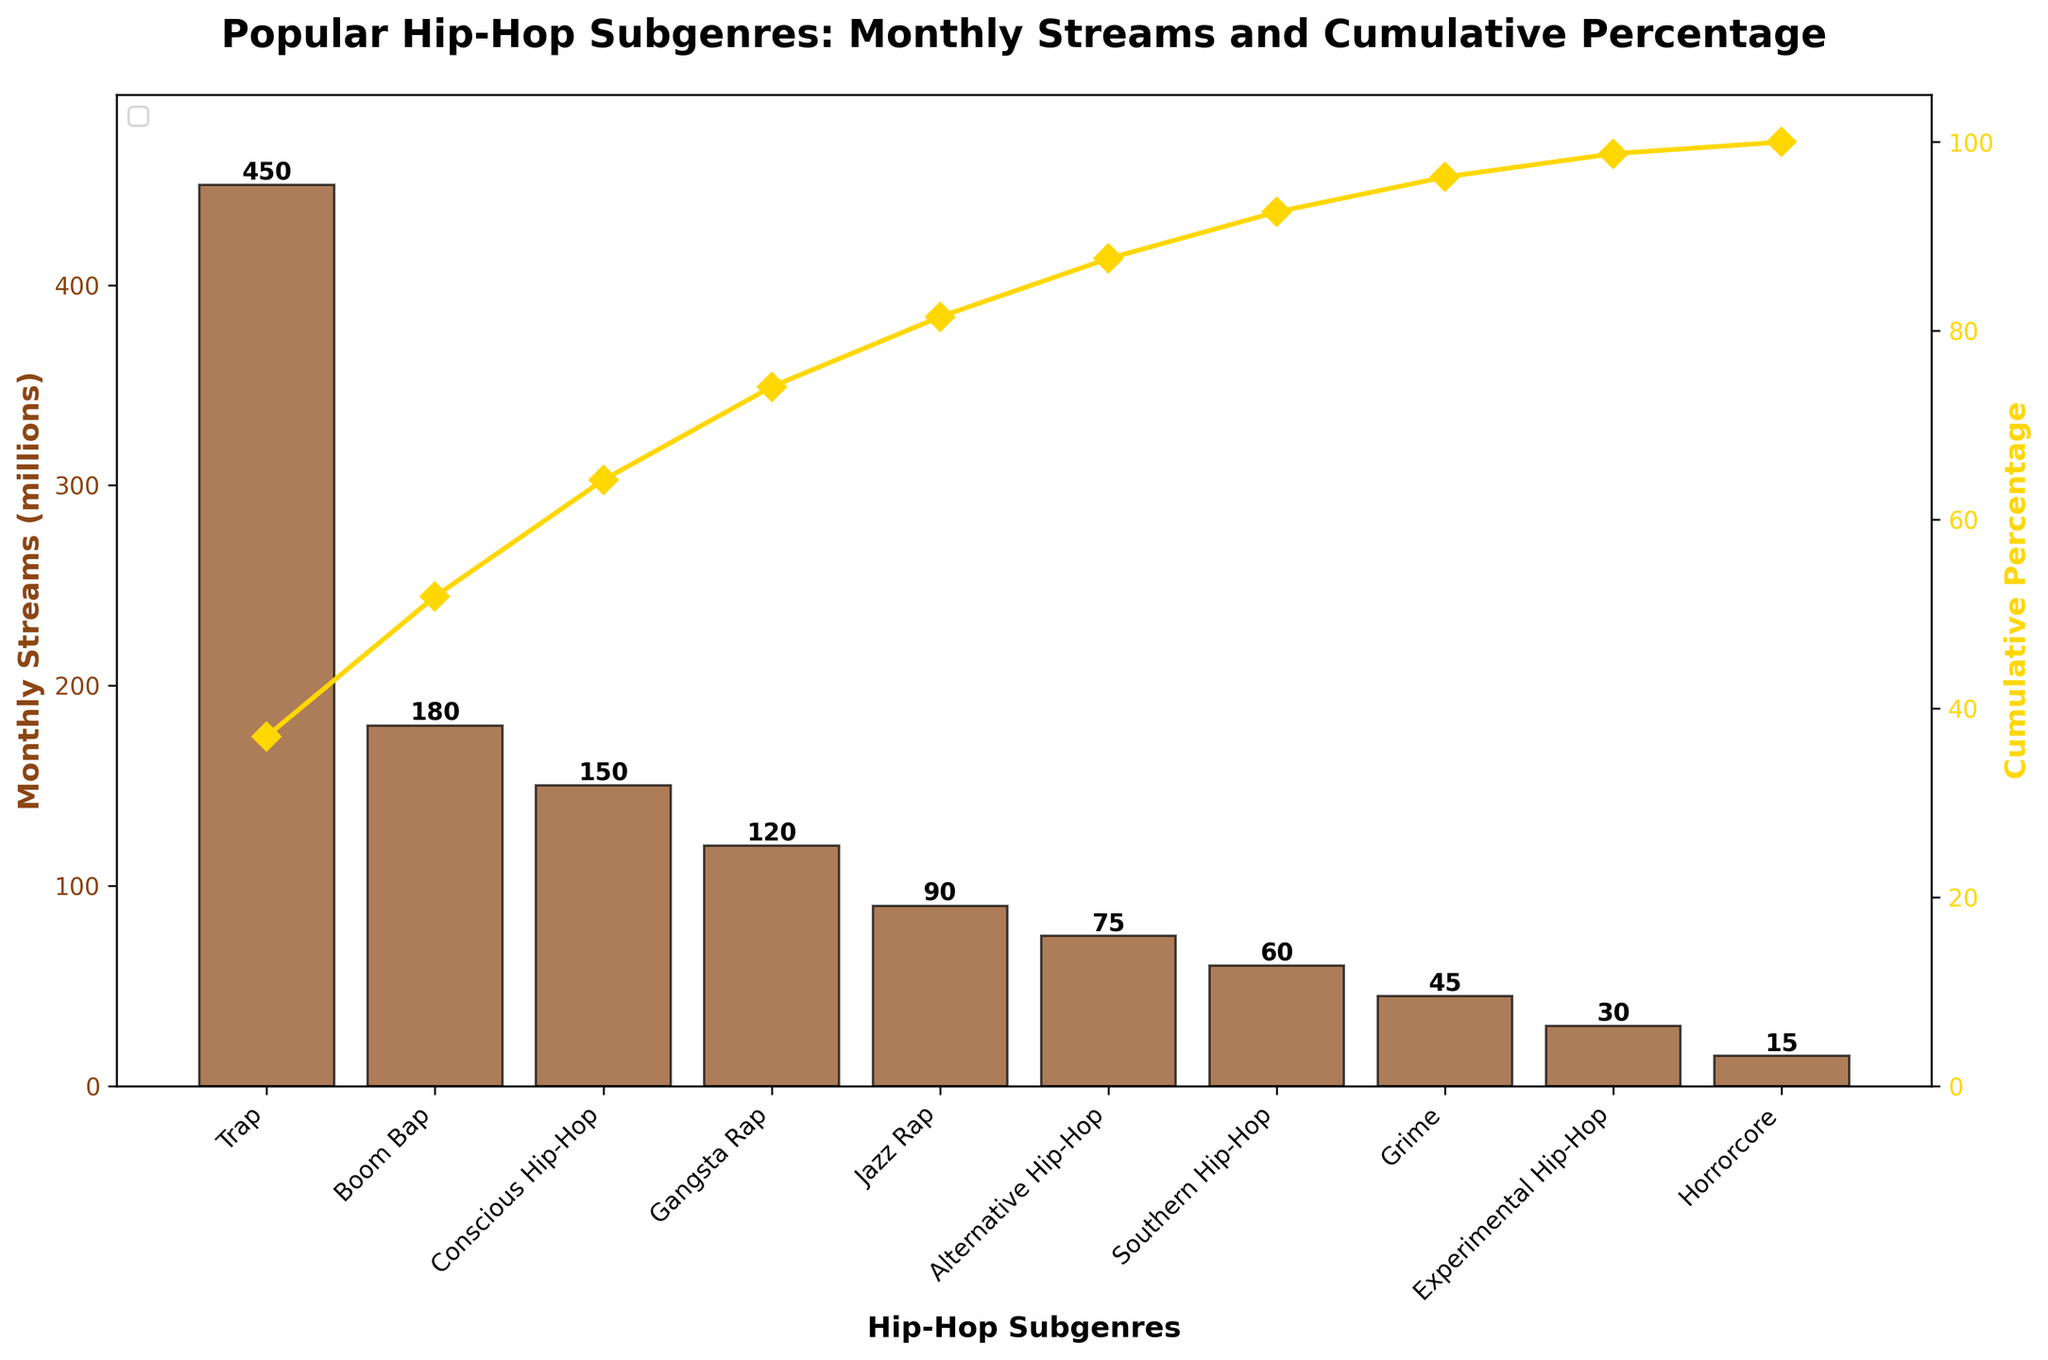What is the title of the figure? The title is usually displayed at the top of the figure and provides a brief description of the chart. In this case, it is written in bold and is clearly visible. The title is "Popular Hip-Hop Subgenres: Monthly Streams and Cumulative Percentage"
Answer: Popular Hip-Hop Subgenres: Monthly Streams and Cumulative Percentage Which subgenre has the highest monthly streams? To find the subgenre with the highest monthly streams, observe the height of the bars. The tallest bar represents the subgenre with the highest streams, which is the first bar since the data is sorted in descending order.
Answer: Trap What is the cumulative percentage for Alternative Hip-Hop? Locate the position of "Alternative Hip-Hop" on the x-axis. Then, refer to the line plot that shows cumulative percentages. The value where this line intersects at "Alternative Hip-Hop" is the desired cumulative percentage.
Answer: Approximately 84% How many subgenres have monthly streams above 100 million? Observe the bar chart and count the number of bars that exceed the 100 million mark on the y-axis.
Answer: Three (Trap, Boom Bap, Conscious Hip-Hop) What is the difference in monthly streams between Trap and Grime? Look at the heights of the bars for Trap and Grime. Trap has 450 million streams, and Grime has 45 million streams. Subtract the smaller value from the larger value (450 - 45).
Answer: 405 million How does the number of monthly streams for Conscious Hip-Hop compare to Gangsta Rap? Compare the heights of the bars for Conscious Hip-Hop and Gangsta Rap. Conscious Hip-Hop has 150 million streams, while Gangsta Rap has 120 million streams.
Answer: Conscious Hip-Hop is higher by 30 million streams Which subgenres contribute to the first 50% of the cumulative percentage? Identify where the cumulative percentage line crosses the 50% mark on the secondary y-axis and note the subgenres up to that point. The subgenres until Conscious Hip-Hop (Trap, Boom Bap, Compact Hip-Hop) contribute to the first 50%.
Answer: Trap, Boom Bap, Conscious Hip-Hop What is the monthly streams value and corresponding cumulative percentage for Jazz Rap? For Jazz Rap, look at the bar value to get monthly streams (90 million) and find the cumulative percentage where the line intersects Jazz Rap.
Answer: 90 million streams and approximately 82% What is the average monthly streams for the subgenres listed? Sum all the monthly streams and divide by the number of subgenres. Total is 1200 million streams, and there are 10 subgenres (1200 / 10).
Answer: 120 million 